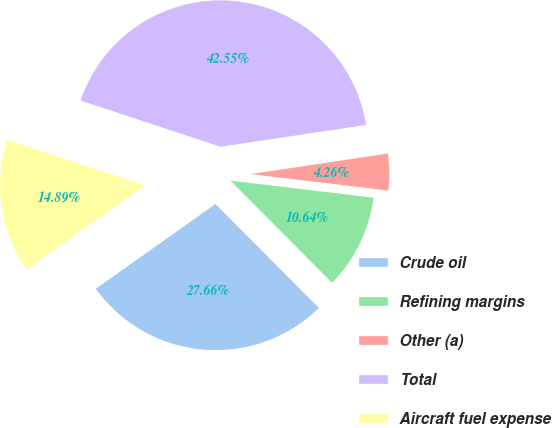Convert chart to OTSL. <chart><loc_0><loc_0><loc_500><loc_500><pie_chart><fcel>Crude oil<fcel>Refining margins<fcel>Other (a)<fcel>Total<fcel>Aircraft fuel expense<nl><fcel>27.66%<fcel>10.64%<fcel>4.26%<fcel>42.55%<fcel>14.89%<nl></chart> 